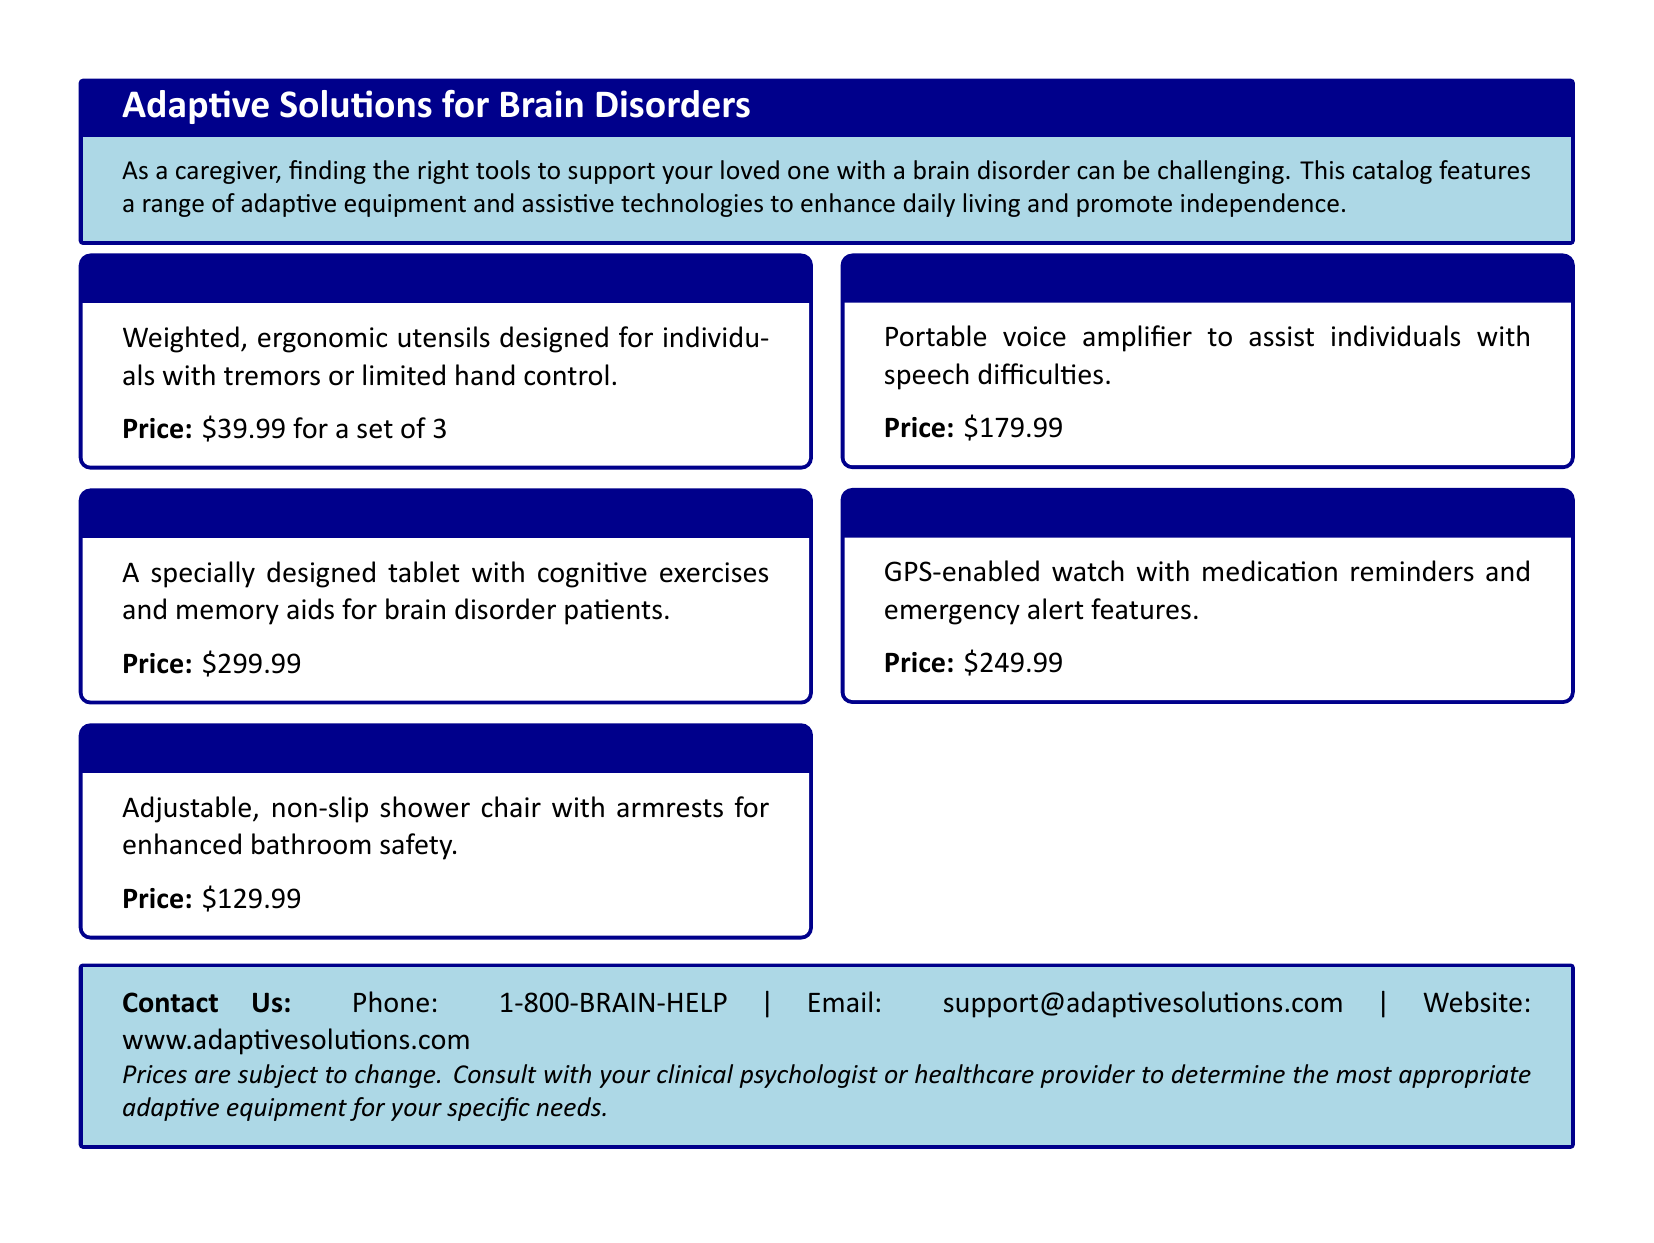What is the price of the NeuroGrip Utensils? The price of NeuroGrip Utensils is listed in the document as $39.99 for a set of 3.
Answer: $39.99 for a set of 3 How many products are featured in the catalog? The document lists five distinct products within the adaptive equipment category.
Answer: 5 What features does the CognitivePal Tablet provide? The CognitivePal Tablet includes cognitive exercises and memory aids for brain disorder patients, as described.
Answer: Cognitive exercises and memory aids What is the purpose of the VoiceAmp Communication Device? The document states that the VoiceAmp Communication Device is designed to assist individuals with speech difficulties.
Answer: Assist individuals with speech difficulties Which product has a GPS-enabled feature? The MemoryMate Smart Watch is highlighted as having GPS-enabled capabilities and medication reminders.
Answer: MemoryMate Smart Watch What is the contact email provided in the document? The contact email for inquiries is support@adaptivesolutions.com, as mentioned in the contact information section.
Answer: support@adaptivesolutions.com Which item is characterized as adjustable and non-slip? The SafeStep Shower Chair is specifically noted for being adjustable and non-slip for enhanced safety.
Answer: SafeStep Shower Chair How much does the MemoryMate Smart Watch cost? The document clearly states the price of the MemoryMate Smart Watch as $249.99.
Answer: $249.99 